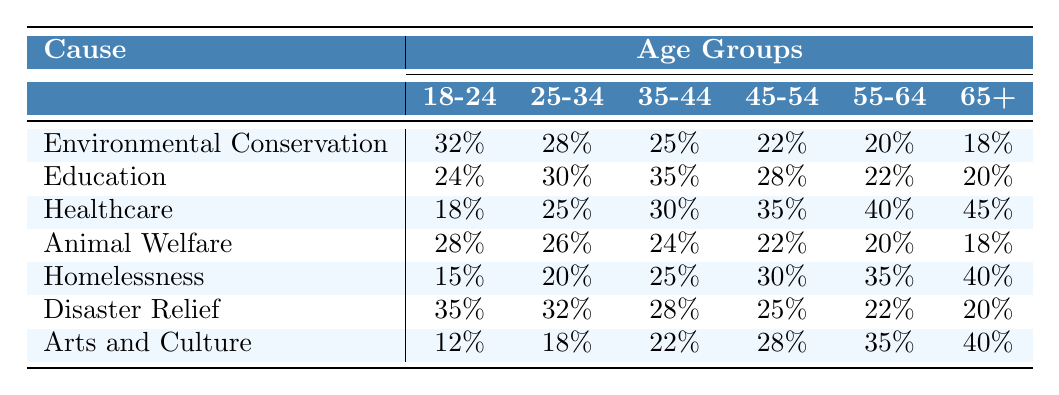What is the engagement rate for Environmental Conservation among those aged 18-24? Referring to the table, the engagement rate for Environmental Conservation in the age group 18-24 is 32%.
Answer: 32% Which cause has the highest engagement rate among individuals aged 35-44? By looking at the table, Healthcare has the highest engagement rate at 30% among people aged 35-44.
Answer: Healthcare What is the average engagement rate for the age group 55-64 across all causes? The engagement rates for the age group 55-64 are 20%, 22%, 40%, 20%, 35%, and 40%. Summing these gives 20+22+40+20+35+40 = 177. There are 6 values, so the average is 177/6 = 29.5%.
Answer: 29.5% Is the engagement rate for Homelessness higher among those aged 45-54 than for Animal Welfare in the same age group? For Homelessness, the engagement rate at 45-54 is 30%, and for Animal Welfare, it is 22%. Since 30% is greater than 22%, the statement is true.
Answer: Yes What is the difference in engagement rates between the youngest (18-24) and the oldest (65+) age groups for Disaster Relief? The engagement rate for Disaster Relief in the 18-24 age group is 35%, and for 65+, it is 20%. The difference is 35% - 20% = 15%.
Answer: 15% Which cause has the lowest engagement rate across all age groups? Examining the table, Arts and Culture has the lowest engagement rate of 12% in the 18-24 age group.
Answer: Arts and Culture Among all causes, which age group sees the highest engagement rate for Education? The highest engagement rate for Education appears in the 35-44 age group at 35%.
Answer: 35% What is the median engagement rate for the age group 25-34 from all causes? The engagement rates for the age group 25-34 are 28%, 30%, 25%, 26%, 20%, 32%, and 18%. Arranging in order gives 18%, 20%, 25%, 26%, 28%, 30%, 32%. The median (middle value) is 26%.
Answer: 26% Is there a cause where individuals aged 65+ have a higher engagement rate than those aged 55-64? Looking at the table, 65+ has engagement rates of 40% for both Healthcare and Arts and Culture, while the highest for 55-64 is 40% (Arts and Culture). Thus, there is no cause where 65+ is higher.
Answer: No What is the total engagement rate for the age group 45-54 across all causes? The engagement rates for 45-54 are 22%, 28%, 35%, 22%, 30%, 25%, and 28%. Summing these gives 22 + 28 + 35 + 22 + 30 + 25 + 28 = 190%.
Answer: 190% 